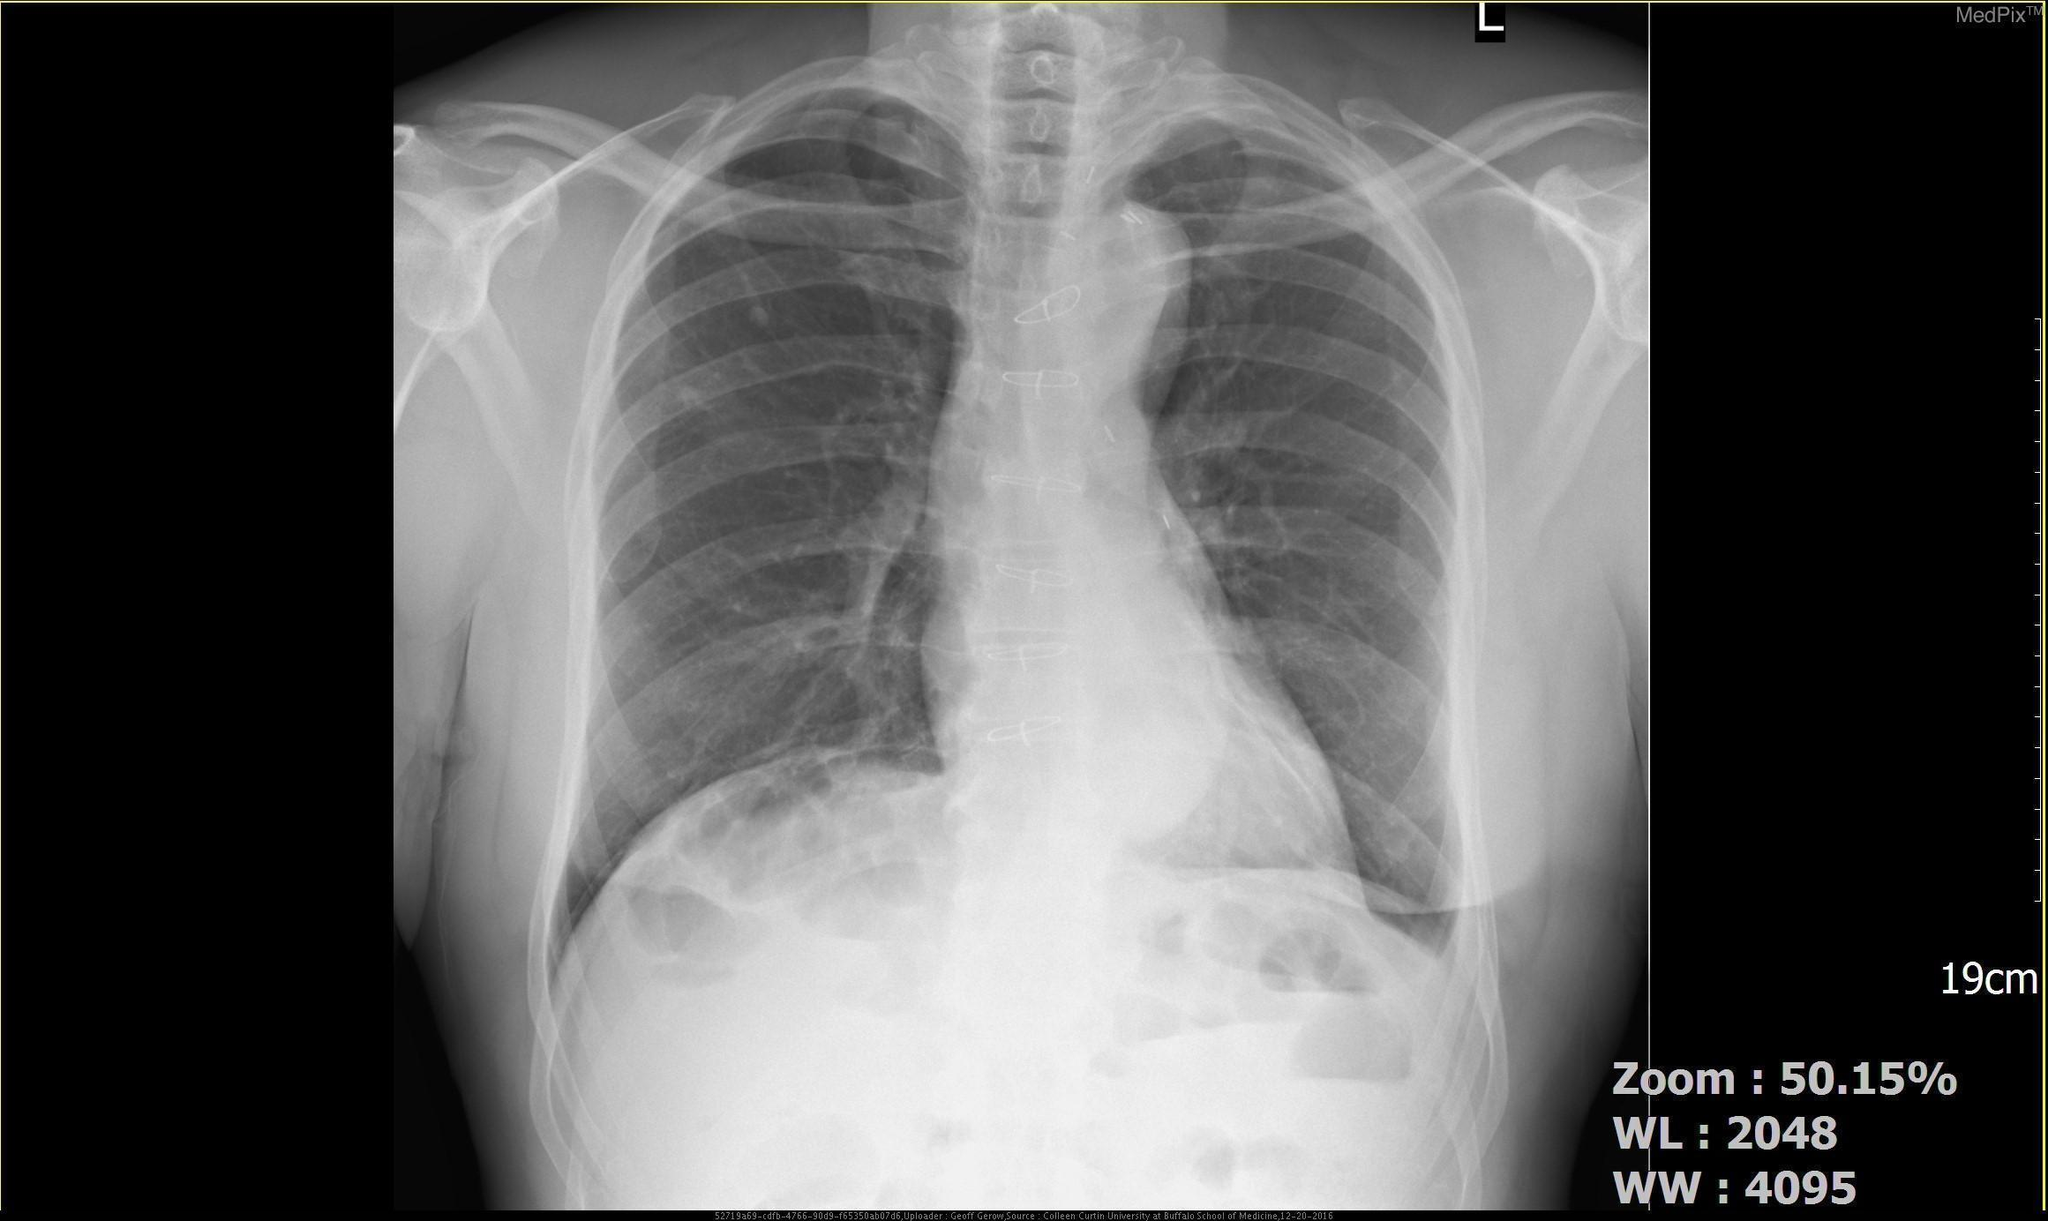Does this radiograph contain parts of the cardiovascular system?
Write a very short answer. Yes. Is the heart enlarged?
Write a very short answer. No. Was this image taken in the ap or pa plane?
Give a very brief answer. Pa. Which rib is fractured?
Short answer required. 3rd rib. Is this a ct scan?
Quick response, please. No. What is the difference between the left and right costophrenic angles?
Be succinct. The left costophrenic angle is blunted. 